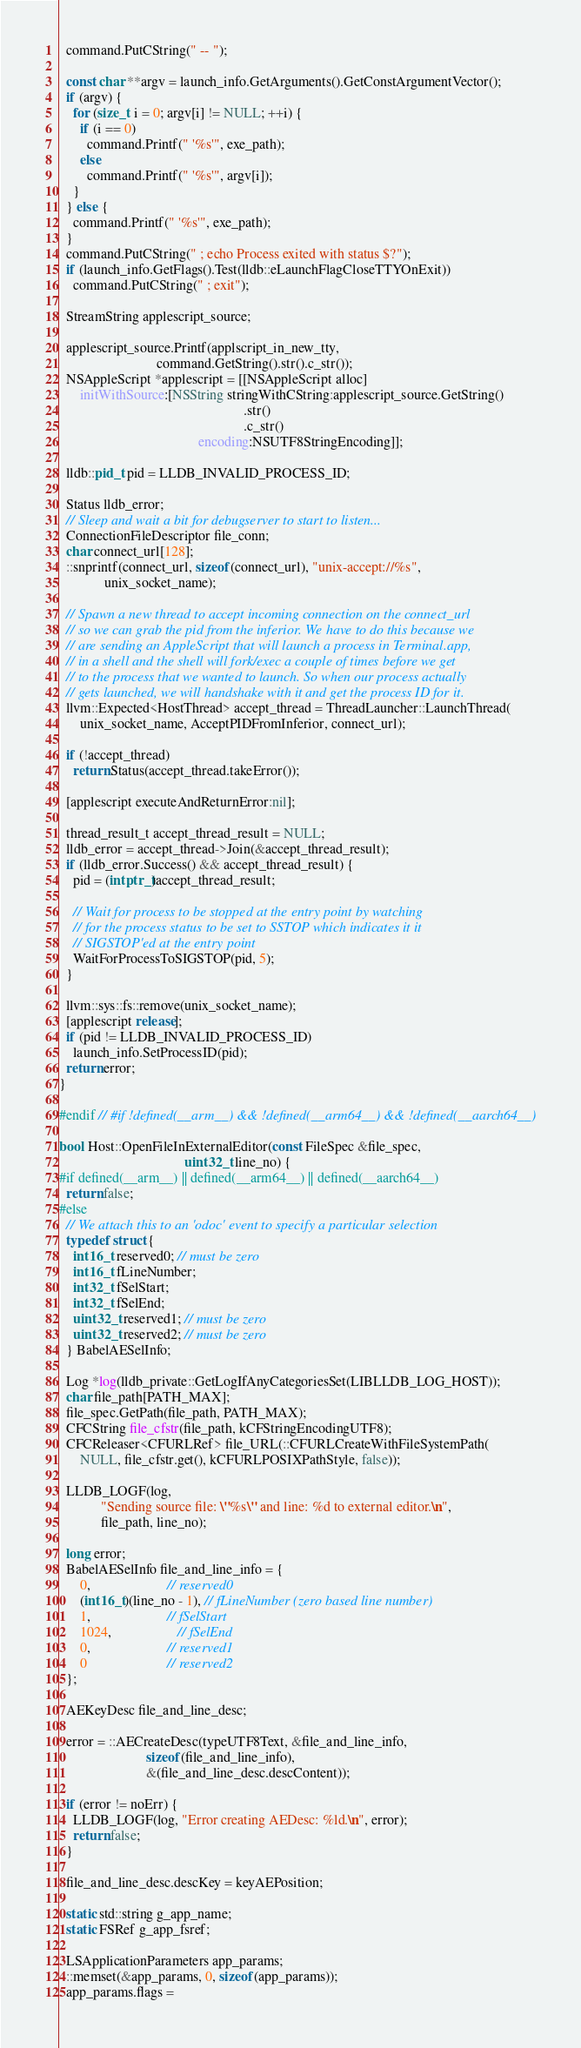Convert code to text. <code><loc_0><loc_0><loc_500><loc_500><_ObjectiveC_>
  command.PutCString(" -- ");

  const char **argv = launch_info.GetArguments().GetConstArgumentVector();
  if (argv) {
    for (size_t i = 0; argv[i] != NULL; ++i) {
      if (i == 0)
        command.Printf(" '%s'", exe_path);
      else
        command.Printf(" '%s'", argv[i]);
    }
  } else {
    command.Printf(" '%s'", exe_path);
  }
  command.PutCString(" ; echo Process exited with status $?");
  if (launch_info.GetFlags().Test(lldb::eLaunchFlagCloseTTYOnExit))
    command.PutCString(" ; exit");

  StreamString applescript_source;

  applescript_source.Printf(applscript_in_new_tty,
                            command.GetString().str().c_str());
  NSAppleScript *applescript = [[NSAppleScript alloc]
      initWithSource:[NSString stringWithCString:applescript_source.GetString()
                                                     .str()
                                                     .c_str()
                                        encoding:NSUTF8StringEncoding]];

  lldb::pid_t pid = LLDB_INVALID_PROCESS_ID;

  Status lldb_error;
  // Sleep and wait a bit for debugserver to start to listen...
  ConnectionFileDescriptor file_conn;
  char connect_url[128];
  ::snprintf(connect_url, sizeof(connect_url), "unix-accept://%s",
             unix_socket_name);

  // Spawn a new thread to accept incoming connection on the connect_url
  // so we can grab the pid from the inferior. We have to do this because we
  // are sending an AppleScript that will launch a process in Terminal.app,
  // in a shell and the shell will fork/exec a couple of times before we get
  // to the process that we wanted to launch. So when our process actually
  // gets launched, we will handshake with it and get the process ID for it.
  llvm::Expected<HostThread> accept_thread = ThreadLauncher::LaunchThread(
      unix_socket_name, AcceptPIDFromInferior, connect_url);

  if (!accept_thread)
    return Status(accept_thread.takeError());

  [applescript executeAndReturnError:nil];

  thread_result_t accept_thread_result = NULL;
  lldb_error = accept_thread->Join(&accept_thread_result);
  if (lldb_error.Success() && accept_thread_result) {
    pid = (intptr_t)accept_thread_result;

    // Wait for process to be stopped at the entry point by watching
    // for the process status to be set to SSTOP which indicates it it
    // SIGSTOP'ed at the entry point
    WaitForProcessToSIGSTOP(pid, 5);
  }

  llvm::sys::fs::remove(unix_socket_name);
  [applescript release];
  if (pid != LLDB_INVALID_PROCESS_ID)
    launch_info.SetProcessID(pid);
  return error;
}

#endif // #if !defined(__arm__) && !defined(__arm64__) && !defined(__aarch64__)

bool Host::OpenFileInExternalEditor(const FileSpec &file_spec,
                                    uint32_t line_no) {
#if defined(__arm__) || defined(__arm64__) || defined(__aarch64__)
  return false;
#else
  // We attach this to an 'odoc' event to specify a particular selection
  typedef struct {
    int16_t reserved0; // must be zero
    int16_t fLineNumber;
    int32_t fSelStart;
    int32_t fSelEnd;
    uint32_t reserved1; // must be zero
    uint32_t reserved2; // must be zero
  } BabelAESelInfo;

  Log *log(lldb_private::GetLogIfAnyCategoriesSet(LIBLLDB_LOG_HOST));
  char file_path[PATH_MAX];
  file_spec.GetPath(file_path, PATH_MAX);
  CFCString file_cfstr(file_path, kCFStringEncodingUTF8);
  CFCReleaser<CFURLRef> file_URL(::CFURLCreateWithFileSystemPath(
      NULL, file_cfstr.get(), kCFURLPOSIXPathStyle, false));

  LLDB_LOGF(log,
            "Sending source file: \"%s\" and line: %d to external editor.\n",
            file_path, line_no);

  long error;
  BabelAESelInfo file_and_line_info = {
      0,                      // reserved0
      (int16_t)(line_no - 1), // fLineNumber (zero based line number)
      1,                      // fSelStart
      1024,                   // fSelEnd
      0,                      // reserved1
      0                       // reserved2
  };

  AEKeyDesc file_and_line_desc;

  error = ::AECreateDesc(typeUTF8Text, &file_and_line_info,
                         sizeof(file_and_line_info),
                         &(file_and_line_desc.descContent));

  if (error != noErr) {
    LLDB_LOGF(log, "Error creating AEDesc: %ld.\n", error);
    return false;
  }

  file_and_line_desc.descKey = keyAEPosition;

  static std::string g_app_name;
  static FSRef g_app_fsref;

  LSApplicationParameters app_params;
  ::memset(&app_params, 0, sizeof(app_params));
  app_params.flags =</code> 